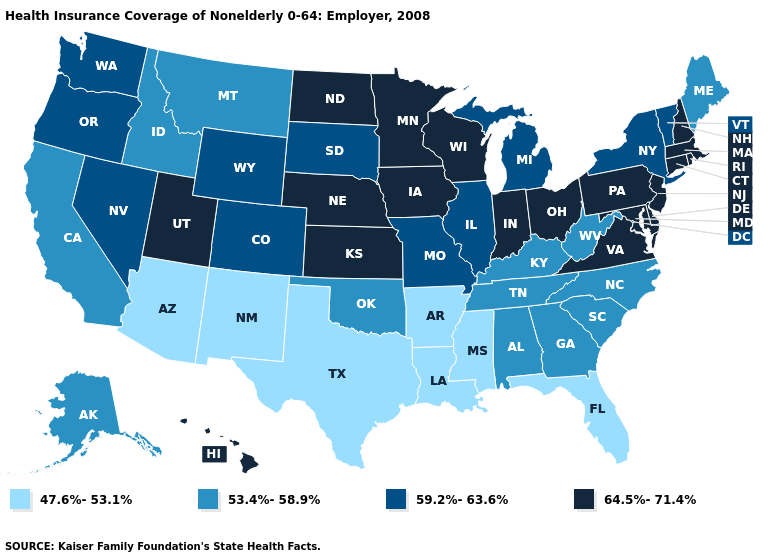How many symbols are there in the legend?
Answer briefly. 4. What is the highest value in states that border Pennsylvania?
Concise answer only. 64.5%-71.4%. What is the value of Delaware?
Write a very short answer. 64.5%-71.4%. Name the states that have a value in the range 59.2%-63.6%?
Short answer required. Colorado, Illinois, Michigan, Missouri, Nevada, New York, Oregon, South Dakota, Vermont, Washington, Wyoming. Which states have the lowest value in the MidWest?
Write a very short answer. Illinois, Michigan, Missouri, South Dakota. Does Michigan have a higher value than Maryland?
Answer briefly. No. Does South Dakota have the highest value in the USA?
Quick response, please. No. What is the value of Florida?
Write a very short answer. 47.6%-53.1%. How many symbols are there in the legend?
Keep it brief. 4. Does Wyoming have the highest value in the USA?
Concise answer only. No. Does Maryland have a higher value than Arizona?
Be succinct. Yes. Is the legend a continuous bar?
Write a very short answer. No. What is the value of Oregon?
Write a very short answer. 59.2%-63.6%. Does Hawaii have the highest value in the West?
Concise answer only. Yes. 